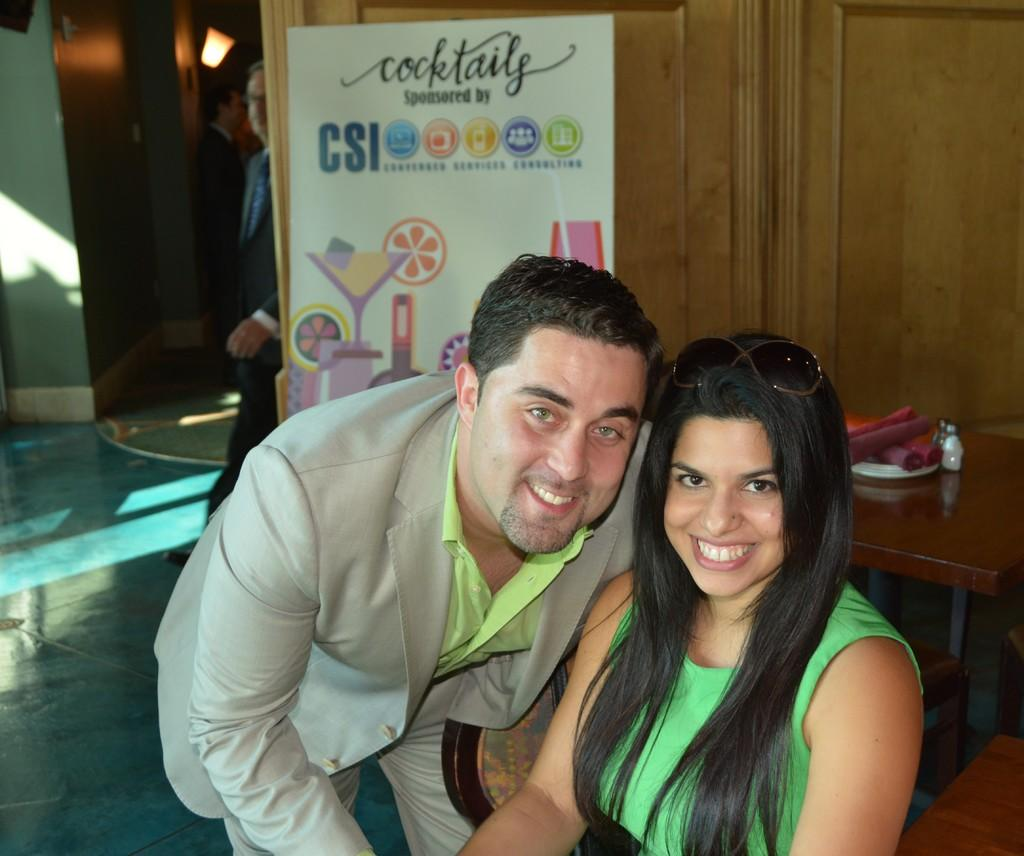What is the woman in the image doing? The woman is sitting on a chair in the image. What is the man in the image doing? The man is standing in the image. What can be found on the table in the image? There is a table with items on it in the image. What is hanging or displayed in the image? There is a banner in the image. Can you describe any activity happening in the background of the image? Another person is walking in the background of the image. What type of order is being placed by the woman in the image? There is no indication in the image that the woman is placing an order, as there is no context or setting provided for such an action. 